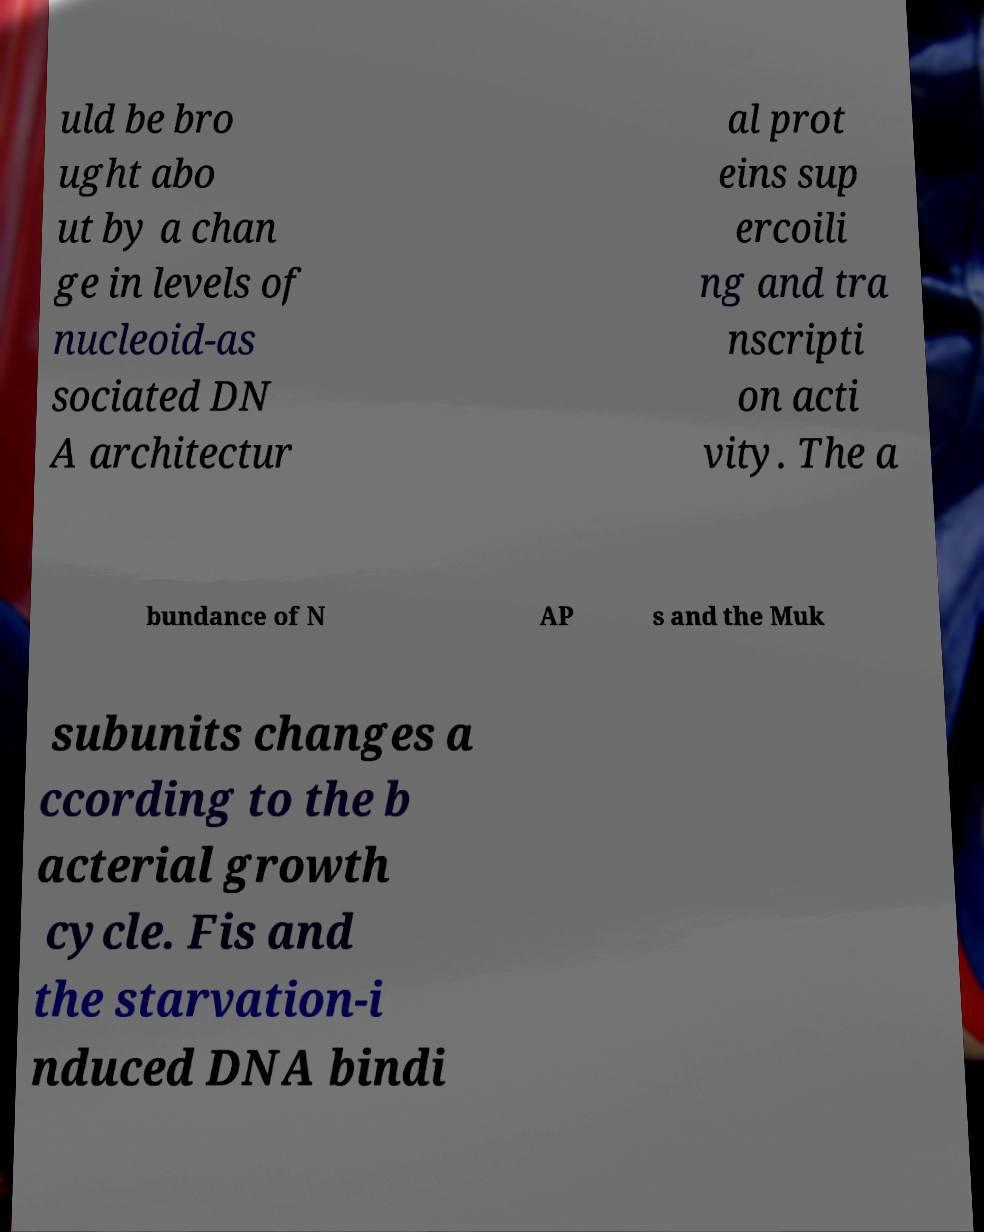Can you accurately transcribe the text from the provided image for me? uld be bro ught abo ut by a chan ge in levels of nucleoid-as sociated DN A architectur al prot eins sup ercoili ng and tra nscripti on acti vity. The a bundance of N AP s and the Muk subunits changes a ccording to the b acterial growth cycle. Fis and the starvation-i nduced DNA bindi 